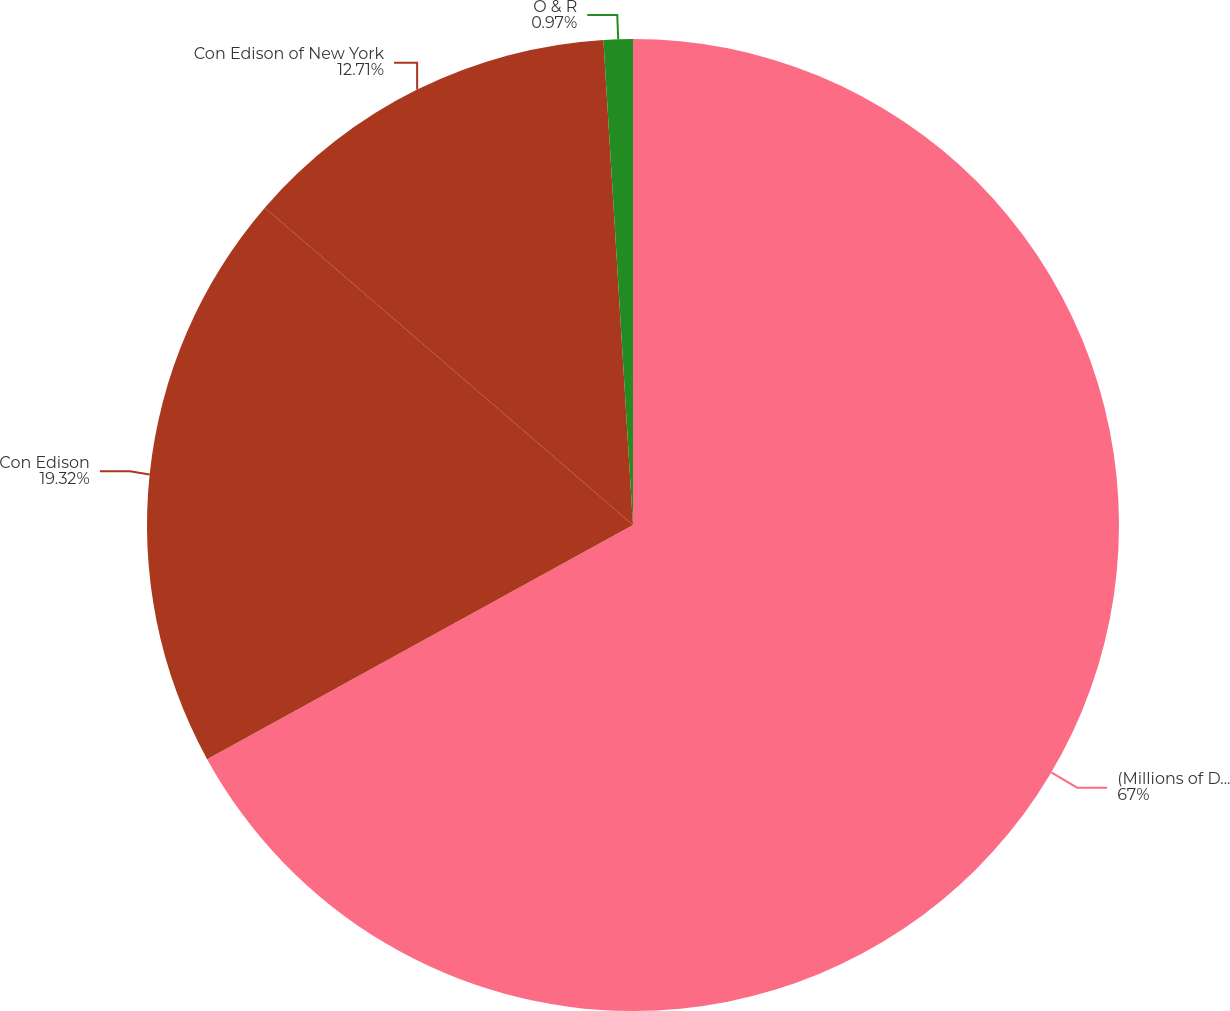Convert chart. <chart><loc_0><loc_0><loc_500><loc_500><pie_chart><fcel>(Millions of Dollars)<fcel>Con Edison<fcel>Con Edison of New York<fcel>O & R<nl><fcel>67.0%<fcel>19.32%<fcel>12.71%<fcel>0.97%<nl></chart> 